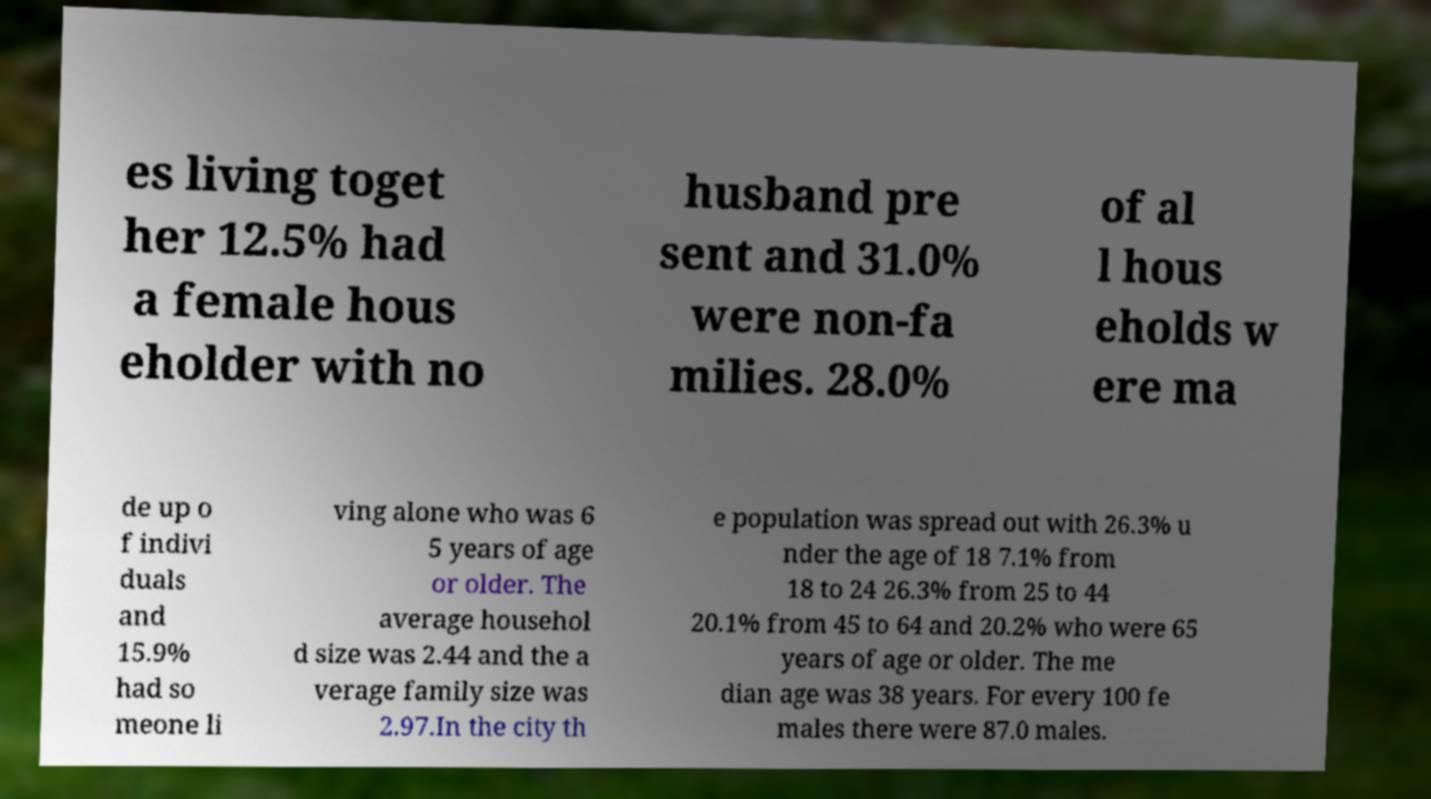Please read and relay the text visible in this image. What does it say? es living toget her 12.5% had a female hous eholder with no husband pre sent and 31.0% were non-fa milies. 28.0% of al l hous eholds w ere ma de up o f indivi duals and 15.9% had so meone li ving alone who was 6 5 years of age or older. The average househol d size was 2.44 and the a verage family size was 2.97.In the city th e population was spread out with 26.3% u nder the age of 18 7.1% from 18 to 24 26.3% from 25 to 44 20.1% from 45 to 64 and 20.2% who were 65 years of age or older. The me dian age was 38 years. For every 100 fe males there were 87.0 males. 